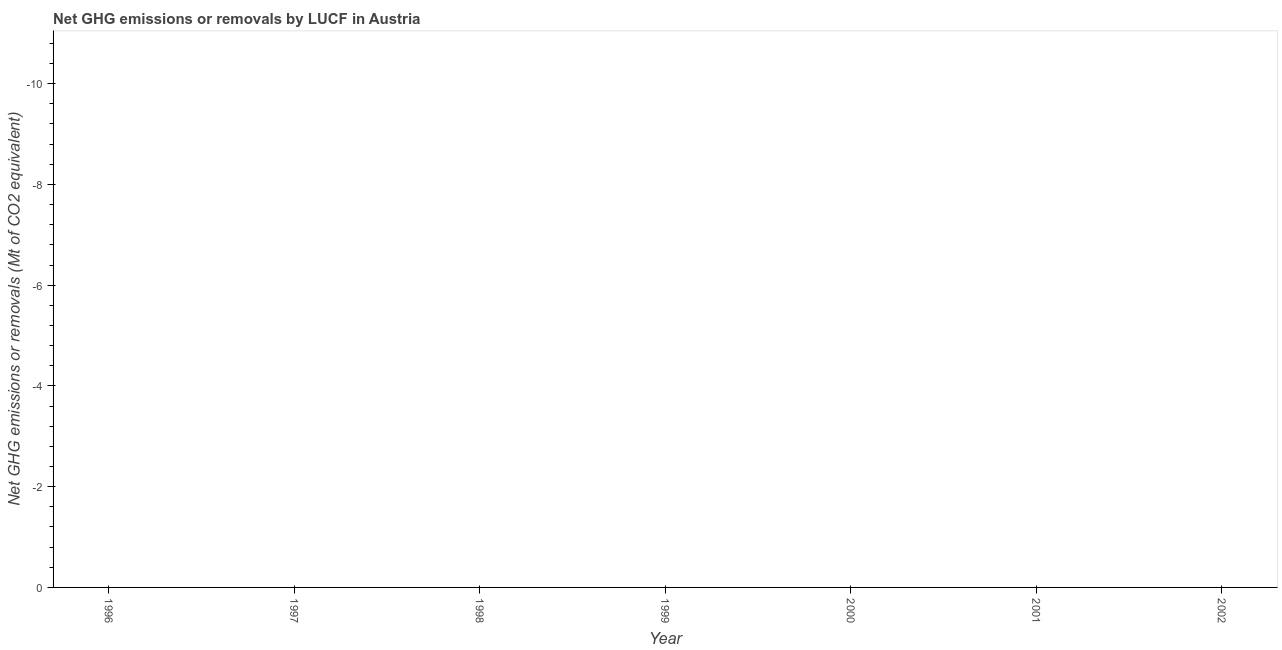What is the ghg net emissions or removals in 1998?
Give a very brief answer. 0. Across all years, what is the minimum ghg net emissions or removals?
Offer a terse response. 0. In how many years, is the ghg net emissions or removals greater than -3.2 Mt?
Your answer should be compact. 0. How many dotlines are there?
Give a very brief answer. 0. Does the graph contain grids?
Give a very brief answer. No. What is the title of the graph?
Keep it short and to the point. Net GHG emissions or removals by LUCF in Austria. What is the label or title of the Y-axis?
Keep it short and to the point. Net GHG emissions or removals (Mt of CO2 equivalent). What is the Net GHG emissions or removals (Mt of CO2 equivalent) in 1996?
Make the answer very short. 0. What is the Net GHG emissions or removals (Mt of CO2 equivalent) in 1997?
Provide a succinct answer. 0. What is the Net GHG emissions or removals (Mt of CO2 equivalent) in 1998?
Keep it short and to the point. 0. What is the Net GHG emissions or removals (Mt of CO2 equivalent) in 1999?
Your answer should be very brief. 0. What is the Net GHG emissions or removals (Mt of CO2 equivalent) in 2002?
Keep it short and to the point. 0. 